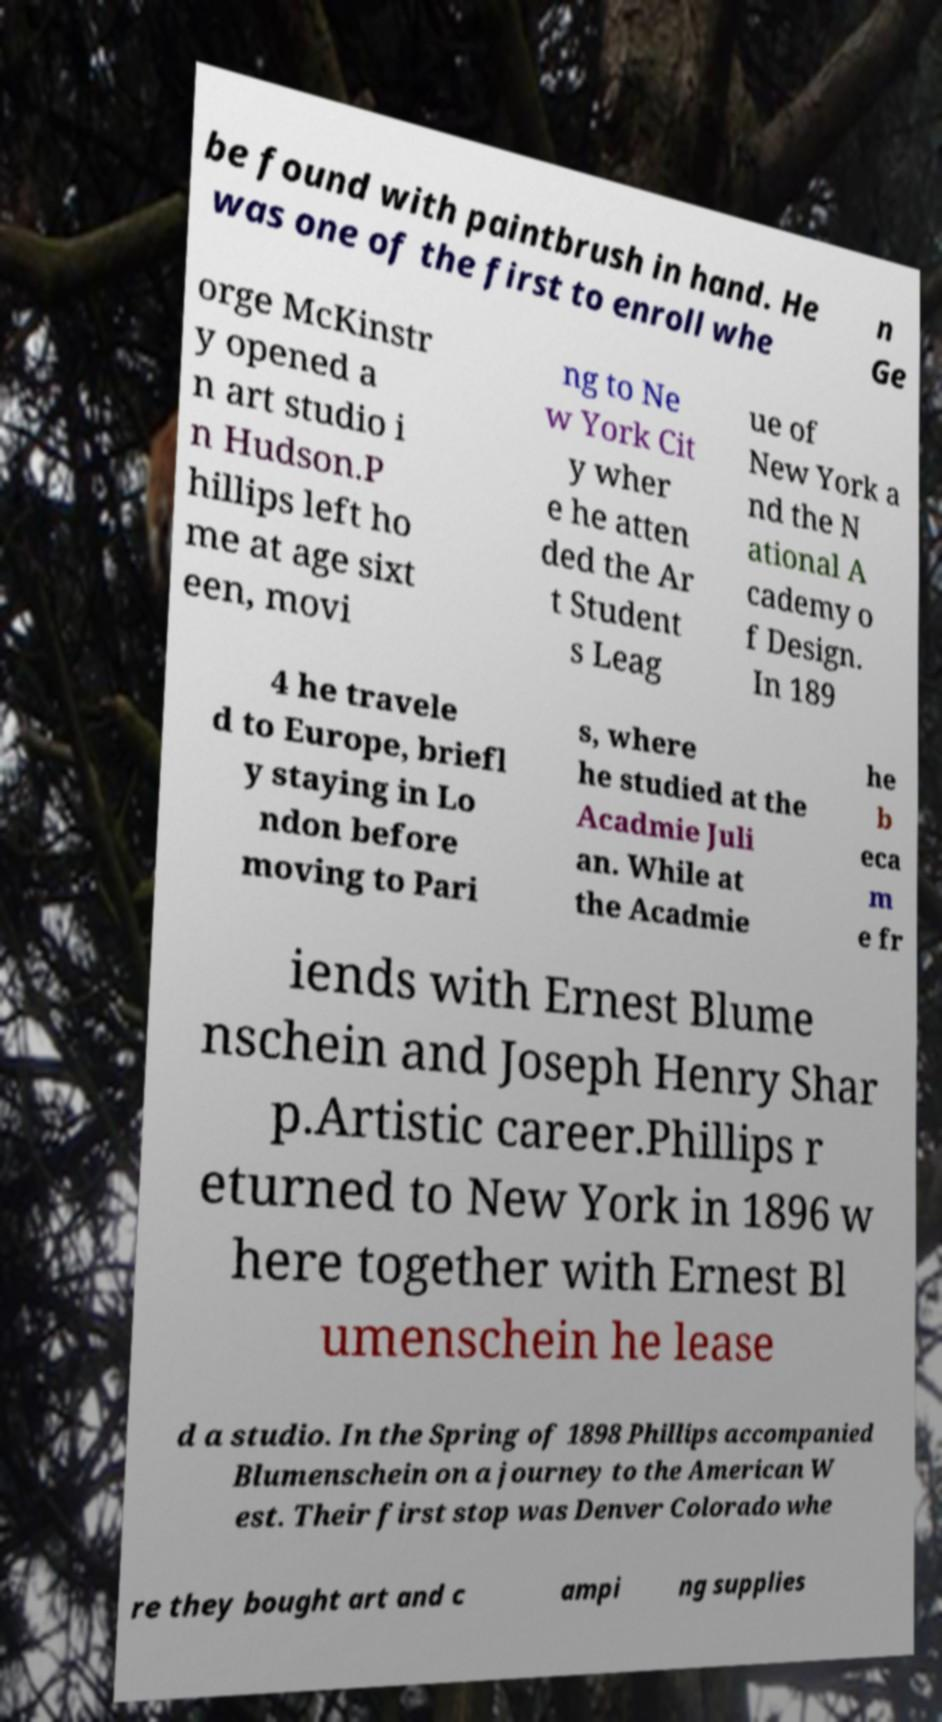There's text embedded in this image that I need extracted. Can you transcribe it verbatim? be found with paintbrush in hand. He was one of the first to enroll whe n Ge orge McKinstr y opened a n art studio i n Hudson.P hillips left ho me at age sixt een, movi ng to Ne w York Cit y wher e he atten ded the Ar t Student s Leag ue of New York a nd the N ational A cademy o f Design. In 189 4 he travele d to Europe, briefl y staying in Lo ndon before moving to Pari s, where he studied at the Acadmie Juli an. While at the Acadmie he b eca m e fr iends with Ernest Blume nschein and Joseph Henry Shar p.Artistic career.Phillips r eturned to New York in 1896 w here together with Ernest Bl umenschein he lease d a studio. In the Spring of 1898 Phillips accompanied Blumenschein on a journey to the American W est. Their first stop was Denver Colorado whe re they bought art and c ampi ng supplies 